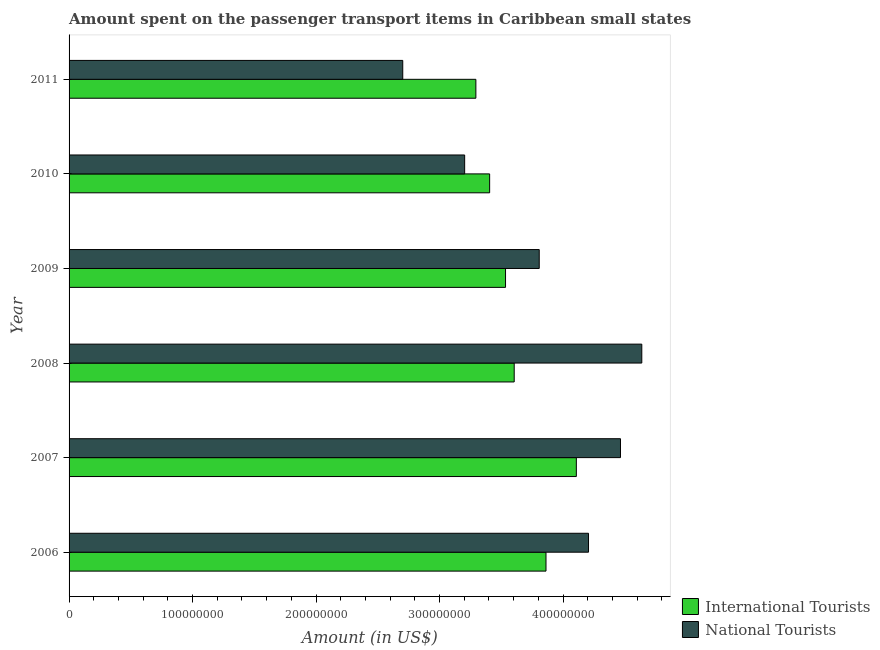How many different coloured bars are there?
Provide a succinct answer. 2. How many groups of bars are there?
Ensure brevity in your answer.  6. Are the number of bars on each tick of the Y-axis equal?
Ensure brevity in your answer.  Yes. How many bars are there on the 2nd tick from the top?
Keep it short and to the point. 2. How many bars are there on the 3rd tick from the bottom?
Keep it short and to the point. 2. In how many cases, is the number of bars for a given year not equal to the number of legend labels?
Provide a short and direct response. 0. What is the amount spent on transport items of international tourists in 2006?
Offer a terse response. 3.86e+08. Across all years, what is the maximum amount spent on transport items of national tourists?
Your answer should be very brief. 4.64e+08. Across all years, what is the minimum amount spent on transport items of international tourists?
Keep it short and to the point. 3.29e+08. In which year was the amount spent on transport items of international tourists maximum?
Make the answer very short. 2007. In which year was the amount spent on transport items of national tourists minimum?
Provide a succinct answer. 2011. What is the total amount spent on transport items of national tourists in the graph?
Make the answer very short. 2.30e+09. What is the difference between the amount spent on transport items of international tourists in 2007 and that in 2011?
Provide a short and direct response. 8.14e+07. What is the difference between the amount spent on transport items of national tourists in 2011 and the amount spent on transport items of international tourists in 2006?
Provide a succinct answer. -1.16e+08. What is the average amount spent on transport items of international tourists per year?
Provide a succinct answer. 3.63e+08. In the year 2007, what is the difference between the amount spent on transport items of national tourists and amount spent on transport items of international tourists?
Keep it short and to the point. 3.57e+07. What is the ratio of the amount spent on transport items of international tourists in 2006 to that in 2010?
Your answer should be very brief. 1.13. Is the difference between the amount spent on transport items of national tourists in 2007 and 2010 greater than the difference between the amount spent on transport items of international tourists in 2007 and 2010?
Ensure brevity in your answer.  Yes. What is the difference between the highest and the second highest amount spent on transport items of national tourists?
Offer a terse response. 1.73e+07. What is the difference between the highest and the lowest amount spent on transport items of international tourists?
Provide a succinct answer. 8.14e+07. In how many years, is the amount spent on transport items of international tourists greater than the average amount spent on transport items of international tourists taken over all years?
Give a very brief answer. 2. Is the sum of the amount spent on transport items of national tourists in 2007 and 2010 greater than the maximum amount spent on transport items of international tourists across all years?
Provide a short and direct response. Yes. What does the 1st bar from the top in 2007 represents?
Your response must be concise. National Tourists. What does the 1st bar from the bottom in 2007 represents?
Your answer should be very brief. International Tourists. How many bars are there?
Provide a succinct answer. 12. Are the values on the major ticks of X-axis written in scientific E-notation?
Provide a succinct answer. No. Does the graph contain any zero values?
Provide a short and direct response. No. Does the graph contain grids?
Provide a short and direct response. No. How many legend labels are there?
Provide a short and direct response. 2. How are the legend labels stacked?
Make the answer very short. Vertical. What is the title of the graph?
Keep it short and to the point. Amount spent on the passenger transport items in Caribbean small states. Does "Urban Population" appear as one of the legend labels in the graph?
Your response must be concise. No. What is the Amount (in US$) in International Tourists in 2006?
Give a very brief answer. 3.86e+08. What is the Amount (in US$) in National Tourists in 2006?
Provide a succinct answer. 4.21e+08. What is the Amount (in US$) in International Tourists in 2007?
Provide a short and direct response. 4.11e+08. What is the Amount (in US$) in National Tourists in 2007?
Make the answer very short. 4.47e+08. What is the Amount (in US$) of International Tourists in 2008?
Ensure brevity in your answer.  3.60e+08. What is the Amount (in US$) in National Tourists in 2008?
Provide a short and direct response. 4.64e+08. What is the Amount (in US$) in International Tourists in 2009?
Your answer should be compact. 3.53e+08. What is the Amount (in US$) in National Tourists in 2009?
Provide a succinct answer. 3.81e+08. What is the Amount (in US$) in International Tourists in 2010?
Your response must be concise. 3.41e+08. What is the Amount (in US$) of National Tourists in 2010?
Give a very brief answer. 3.20e+08. What is the Amount (in US$) in International Tourists in 2011?
Give a very brief answer. 3.29e+08. What is the Amount (in US$) in National Tourists in 2011?
Ensure brevity in your answer.  2.70e+08. Across all years, what is the maximum Amount (in US$) in International Tourists?
Your response must be concise. 4.11e+08. Across all years, what is the maximum Amount (in US$) of National Tourists?
Keep it short and to the point. 4.64e+08. Across all years, what is the minimum Amount (in US$) of International Tourists?
Your answer should be compact. 3.29e+08. Across all years, what is the minimum Amount (in US$) of National Tourists?
Your answer should be compact. 2.70e+08. What is the total Amount (in US$) in International Tourists in the graph?
Your answer should be compact. 2.18e+09. What is the total Amount (in US$) of National Tourists in the graph?
Your answer should be compact. 2.30e+09. What is the difference between the Amount (in US$) of International Tourists in 2006 and that in 2007?
Make the answer very short. -2.46e+07. What is the difference between the Amount (in US$) in National Tourists in 2006 and that in 2007?
Provide a short and direct response. -2.59e+07. What is the difference between the Amount (in US$) in International Tourists in 2006 and that in 2008?
Offer a very short reply. 2.57e+07. What is the difference between the Amount (in US$) in National Tourists in 2006 and that in 2008?
Provide a short and direct response. -4.31e+07. What is the difference between the Amount (in US$) of International Tourists in 2006 and that in 2009?
Your answer should be compact. 3.28e+07. What is the difference between the Amount (in US$) in National Tourists in 2006 and that in 2009?
Keep it short and to the point. 3.99e+07. What is the difference between the Amount (in US$) of International Tourists in 2006 and that in 2010?
Keep it short and to the point. 4.56e+07. What is the difference between the Amount (in US$) of National Tourists in 2006 and that in 2010?
Keep it short and to the point. 1.00e+08. What is the difference between the Amount (in US$) in International Tourists in 2006 and that in 2011?
Provide a short and direct response. 5.68e+07. What is the difference between the Amount (in US$) of National Tourists in 2006 and that in 2011?
Your answer should be very brief. 1.50e+08. What is the difference between the Amount (in US$) in International Tourists in 2007 and that in 2008?
Ensure brevity in your answer.  5.03e+07. What is the difference between the Amount (in US$) of National Tourists in 2007 and that in 2008?
Keep it short and to the point. -1.73e+07. What is the difference between the Amount (in US$) in International Tourists in 2007 and that in 2009?
Your answer should be very brief. 5.73e+07. What is the difference between the Amount (in US$) of National Tourists in 2007 and that in 2009?
Your response must be concise. 6.58e+07. What is the difference between the Amount (in US$) in International Tourists in 2007 and that in 2010?
Make the answer very short. 7.02e+07. What is the difference between the Amount (in US$) of National Tourists in 2007 and that in 2010?
Your response must be concise. 1.26e+08. What is the difference between the Amount (in US$) in International Tourists in 2007 and that in 2011?
Your answer should be very brief. 8.14e+07. What is the difference between the Amount (in US$) in National Tourists in 2007 and that in 2011?
Give a very brief answer. 1.76e+08. What is the difference between the Amount (in US$) in International Tourists in 2008 and that in 2009?
Your response must be concise. 7.02e+06. What is the difference between the Amount (in US$) in National Tourists in 2008 and that in 2009?
Your answer should be compact. 8.31e+07. What is the difference between the Amount (in US$) of International Tourists in 2008 and that in 2010?
Offer a very short reply. 1.99e+07. What is the difference between the Amount (in US$) in National Tourists in 2008 and that in 2010?
Provide a short and direct response. 1.43e+08. What is the difference between the Amount (in US$) in International Tourists in 2008 and that in 2011?
Offer a very short reply. 3.10e+07. What is the difference between the Amount (in US$) of National Tourists in 2008 and that in 2011?
Provide a succinct answer. 1.94e+08. What is the difference between the Amount (in US$) in International Tourists in 2009 and that in 2010?
Make the answer very short. 1.29e+07. What is the difference between the Amount (in US$) in National Tourists in 2009 and that in 2010?
Your answer should be compact. 6.04e+07. What is the difference between the Amount (in US$) of International Tourists in 2009 and that in 2011?
Keep it short and to the point. 2.40e+07. What is the difference between the Amount (in US$) in National Tourists in 2009 and that in 2011?
Offer a very short reply. 1.11e+08. What is the difference between the Amount (in US$) of International Tourists in 2010 and that in 2011?
Keep it short and to the point. 1.11e+07. What is the difference between the Amount (in US$) in National Tourists in 2010 and that in 2011?
Offer a terse response. 5.01e+07. What is the difference between the Amount (in US$) of International Tourists in 2006 and the Amount (in US$) of National Tourists in 2007?
Offer a terse response. -6.03e+07. What is the difference between the Amount (in US$) of International Tourists in 2006 and the Amount (in US$) of National Tourists in 2008?
Give a very brief answer. -7.76e+07. What is the difference between the Amount (in US$) of International Tourists in 2006 and the Amount (in US$) of National Tourists in 2009?
Your response must be concise. 5.48e+06. What is the difference between the Amount (in US$) in International Tourists in 2006 and the Amount (in US$) in National Tourists in 2010?
Make the answer very short. 6.59e+07. What is the difference between the Amount (in US$) in International Tourists in 2006 and the Amount (in US$) in National Tourists in 2011?
Provide a succinct answer. 1.16e+08. What is the difference between the Amount (in US$) in International Tourists in 2007 and the Amount (in US$) in National Tourists in 2008?
Give a very brief answer. -5.30e+07. What is the difference between the Amount (in US$) in International Tourists in 2007 and the Amount (in US$) in National Tourists in 2009?
Provide a short and direct response. 3.01e+07. What is the difference between the Amount (in US$) of International Tourists in 2007 and the Amount (in US$) of National Tourists in 2010?
Offer a very short reply. 9.05e+07. What is the difference between the Amount (in US$) of International Tourists in 2007 and the Amount (in US$) of National Tourists in 2011?
Your response must be concise. 1.41e+08. What is the difference between the Amount (in US$) in International Tourists in 2008 and the Amount (in US$) in National Tourists in 2009?
Ensure brevity in your answer.  -2.03e+07. What is the difference between the Amount (in US$) in International Tourists in 2008 and the Amount (in US$) in National Tourists in 2010?
Provide a short and direct response. 4.01e+07. What is the difference between the Amount (in US$) in International Tourists in 2008 and the Amount (in US$) in National Tourists in 2011?
Offer a terse response. 9.03e+07. What is the difference between the Amount (in US$) in International Tourists in 2009 and the Amount (in US$) in National Tourists in 2010?
Keep it short and to the point. 3.31e+07. What is the difference between the Amount (in US$) of International Tourists in 2009 and the Amount (in US$) of National Tourists in 2011?
Provide a short and direct response. 8.32e+07. What is the difference between the Amount (in US$) in International Tourists in 2010 and the Amount (in US$) in National Tourists in 2011?
Make the answer very short. 7.04e+07. What is the average Amount (in US$) in International Tourists per year?
Keep it short and to the point. 3.63e+08. What is the average Amount (in US$) in National Tourists per year?
Make the answer very short. 3.84e+08. In the year 2006, what is the difference between the Amount (in US$) in International Tourists and Amount (in US$) in National Tourists?
Provide a short and direct response. -3.44e+07. In the year 2007, what is the difference between the Amount (in US$) in International Tourists and Amount (in US$) in National Tourists?
Offer a very short reply. -3.57e+07. In the year 2008, what is the difference between the Amount (in US$) in International Tourists and Amount (in US$) in National Tourists?
Give a very brief answer. -1.03e+08. In the year 2009, what is the difference between the Amount (in US$) of International Tourists and Amount (in US$) of National Tourists?
Give a very brief answer. -2.73e+07. In the year 2010, what is the difference between the Amount (in US$) in International Tourists and Amount (in US$) in National Tourists?
Offer a very short reply. 2.02e+07. In the year 2011, what is the difference between the Amount (in US$) of International Tourists and Amount (in US$) of National Tourists?
Offer a very short reply. 5.92e+07. What is the ratio of the Amount (in US$) of International Tourists in 2006 to that in 2007?
Provide a short and direct response. 0.94. What is the ratio of the Amount (in US$) in National Tourists in 2006 to that in 2007?
Keep it short and to the point. 0.94. What is the ratio of the Amount (in US$) in International Tourists in 2006 to that in 2008?
Keep it short and to the point. 1.07. What is the ratio of the Amount (in US$) in National Tourists in 2006 to that in 2008?
Keep it short and to the point. 0.91. What is the ratio of the Amount (in US$) of International Tourists in 2006 to that in 2009?
Keep it short and to the point. 1.09. What is the ratio of the Amount (in US$) of National Tourists in 2006 to that in 2009?
Offer a terse response. 1.1. What is the ratio of the Amount (in US$) of International Tourists in 2006 to that in 2010?
Provide a short and direct response. 1.13. What is the ratio of the Amount (in US$) of National Tourists in 2006 to that in 2010?
Your answer should be compact. 1.31. What is the ratio of the Amount (in US$) of International Tourists in 2006 to that in 2011?
Make the answer very short. 1.17. What is the ratio of the Amount (in US$) in National Tourists in 2006 to that in 2011?
Your response must be concise. 1.56. What is the ratio of the Amount (in US$) in International Tourists in 2007 to that in 2008?
Give a very brief answer. 1.14. What is the ratio of the Amount (in US$) of National Tourists in 2007 to that in 2008?
Keep it short and to the point. 0.96. What is the ratio of the Amount (in US$) in International Tourists in 2007 to that in 2009?
Offer a very short reply. 1.16. What is the ratio of the Amount (in US$) in National Tourists in 2007 to that in 2009?
Your response must be concise. 1.17. What is the ratio of the Amount (in US$) in International Tourists in 2007 to that in 2010?
Ensure brevity in your answer.  1.21. What is the ratio of the Amount (in US$) in National Tourists in 2007 to that in 2010?
Offer a terse response. 1.39. What is the ratio of the Amount (in US$) of International Tourists in 2007 to that in 2011?
Your answer should be compact. 1.25. What is the ratio of the Amount (in US$) of National Tourists in 2007 to that in 2011?
Give a very brief answer. 1.65. What is the ratio of the Amount (in US$) of International Tourists in 2008 to that in 2009?
Provide a succinct answer. 1.02. What is the ratio of the Amount (in US$) in National Tourists in 2008 to that in 2009?
Your answer should be compact. 1.22. What is the ratio of the Amount (in US$) in International Tourists in 2008 to that in 2010?
Make the answer very short. 1.06. What is the ratio of the Amount (in US$) of National Tourists in 2008 to that in 2010?
Your response must be concise. 1.45. What is the ratio of the Amount (in US$) in International Tourists in 2008 to that in 2011?
Your answer should be compact. 1.09. What is the ratio of the Amount (in US$) of National Tourists in 2008 to that in 2011?
Provide a short and direct response. 1.72. What is the ratio of the Amount (in US$) in International Tourists in 2009 to that in 2010?
Your answer should be compact. 1.04. What is the ratio of the Amount (in US$) in National Tourists in 2009 to that in 2010?
Offer a terse response. 1.19. What is the ratio of the Amount (in US$) in International Tourists in 2009 to that in 2011?
Ensure brevity in your answer.  1.07. What is the ratio of the Amount (in US$) of National Tourists in 2009 to that in 2011?
Give a very brief answer. 1.41. What is the ratio of the Amount (in US$) of International Tourists in 2010 to that in 2011?
Your answer should be compact. 1.03. What is the ratio of the Amount (in US$) of National Tourists in 2010 to that in 2011?
Provide a succinct answer. 1.19. What is the difference between the highest and the second highest Amount (in US$) of International Tourists?
Provide a succinct answer. 2.46e+07. What is the difference between the highest and the second highest Amount (in US$) in National Tourists?
Give a very brief answer. 1.73e+07. What is the difference between the highest and the lowest Amount (in US$) of International Tourists?
Keep it short and to the point. 8.14e+07. What is the difference between the highest and the lowest Amount (in US$) in National Tourists?
Offer a terse response. 1.94e+08. 